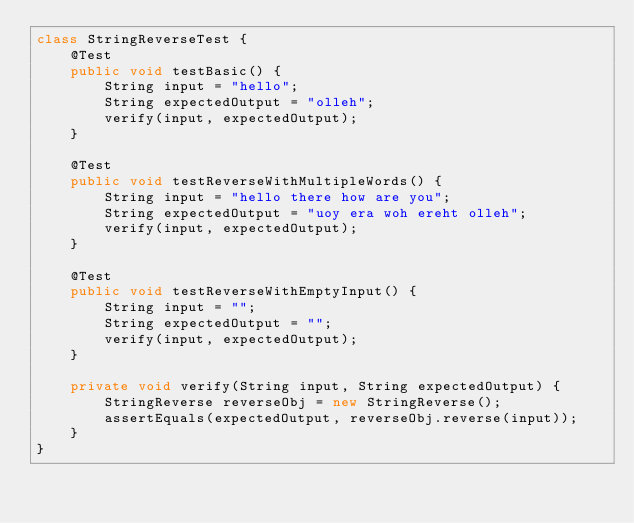Convert code to text. <code><loc_0><loc_0><loc_500><loc_500><_Java_>class StringReverseTest {
    @Test
    public void testBasic() {
        String input = "hello";
        String expectedOutput = "olleh";
        verify(input, expectedOutput);
    }

    @Test
    public void testReverseWithMultipleWords() {
        String input = "hello there how are you";
        String expectedOutput = "uoy era woh ereht olleh";
        verify(input, expectedOutput);
    }

    @Test
    public void testReverseWithEmptyInput() {
        String input = "";
        String expectedOutput = "";
        verify(input, expectedOutput);
    }

    private void verify(String input, String expectedOutput) {
        StringReverse reverseObj = new StringReverse();
        assertEquals(expectedOutput, reverseObj.reverse(input));
    }
}</code> 